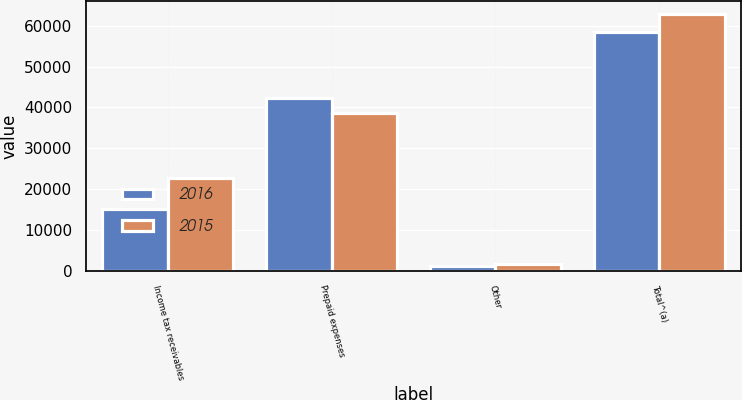<chart> <loc_0><loc_0><loc_500><loc_500><stacked_bar_chart><ecel><fcel>Income tax receivables<fcel>Prepaid expenses<fcel>Other<fcel>Total^(a)<nl><fcel>2016<fcel>15085<fcel>42240<fcel>1254<fcel>58579<nl><fcel>2015<fcel>22649<fcel>38609<fcel>1664<fcel>62922<nl></chart> 